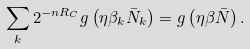Convert formula to latex. <formula><loc_0><loc_0><loc_500><loc_500>\sum _ { k } 2 ^ { - n R _ { C } } g \left ( \eta \beta _ { k } { \bar { N } } _ { k } \right ) = g \left ( \eta \beta { \bar { N } } \right ) .</formula> 